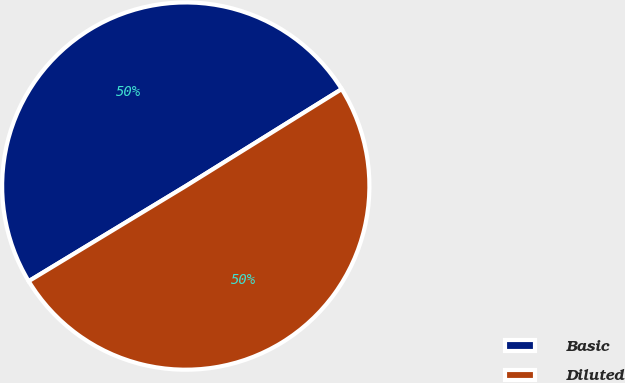Convert chart to OTSL. <chart><loc_0><loc_0><loc_500><loc_500><pie_chart><fcel>Basic<fcel>Diluted<nl><fcel>49.81%<fcel>50.19%<nl></chart> 